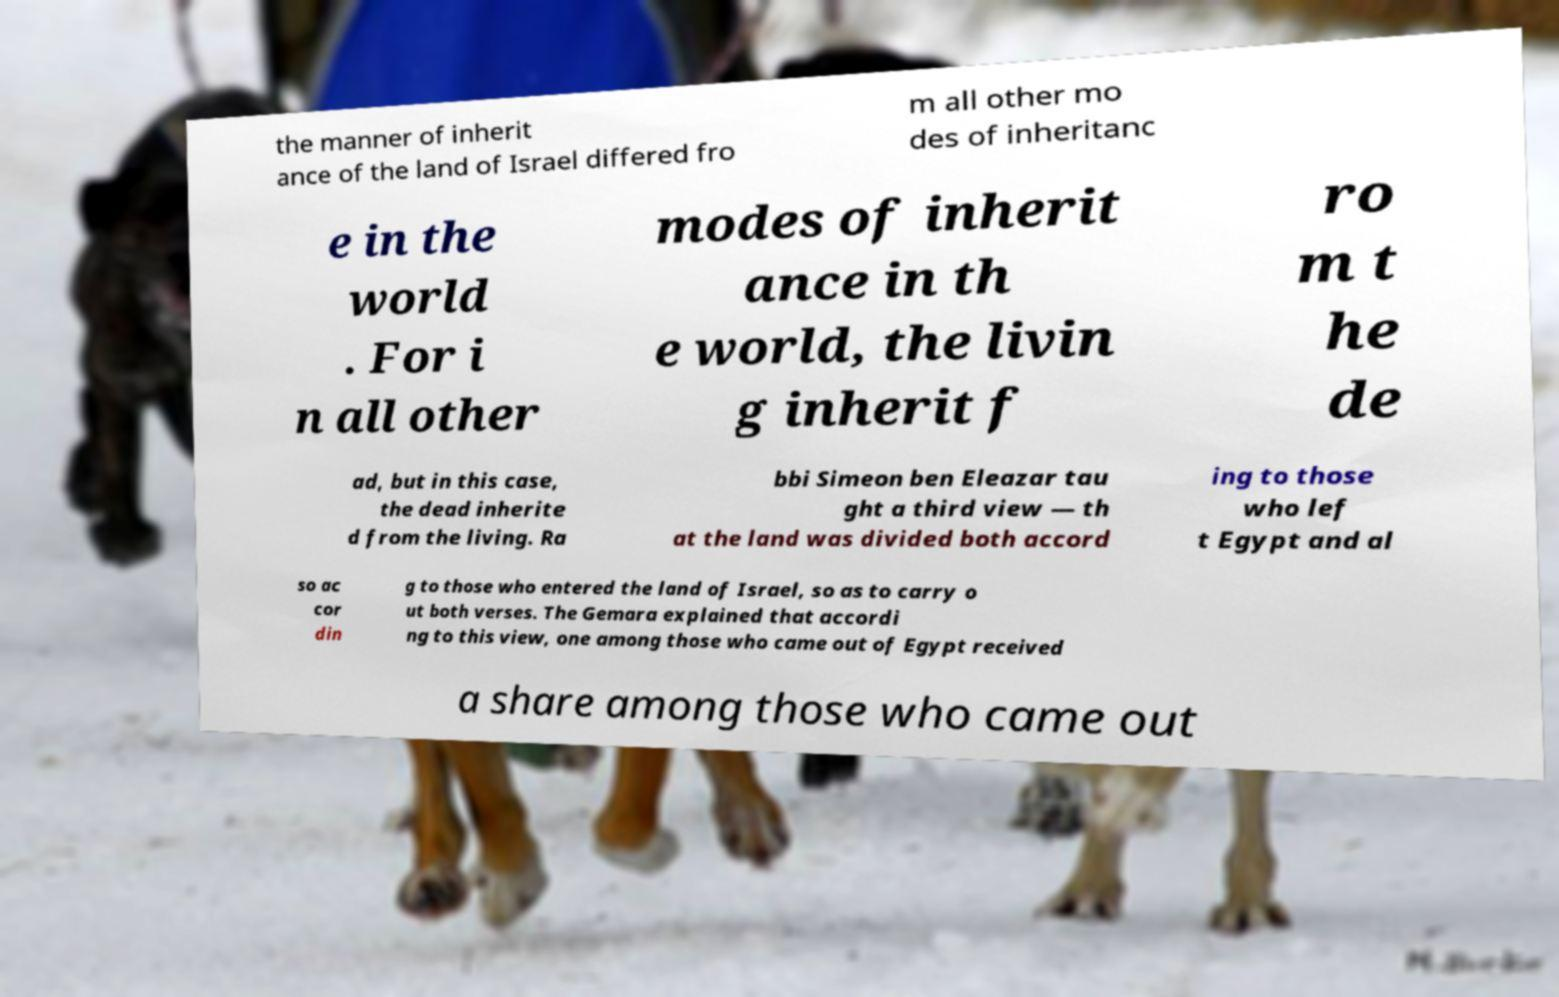Can you read and provide the text displayed in the image?This photo seems to have some interesting text. Can you extract and type it out for me? the manner of inherit ance of the land of Israel differed fro m all other mo des of inheritanc e in the world . For i n all other modes of inherit ance in th e world, the livin g inherit f ro m t he de ad, but in this case, the dead inherite d from the living. Ra bbi Simeon ben Eleazar tau ght a third view — th at the land was divided both accord ing to those who lef t Egypt and al so ac cor din g to those who entered the land of Israel, so as to carry o ut both verses. The Gemara explained that accordi ng to this view, one among those who came out of Egypt received a share among those who came out 